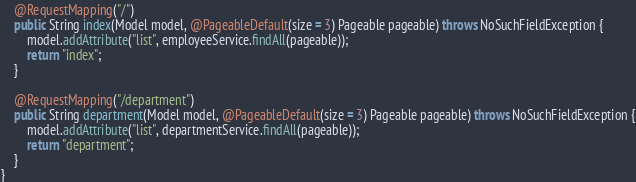<code> <loc_0><loc_0><loc_500><loc_500><_Java_>    @RequestMapping("/")
    public String index(Model model, @PageableDefault(size = 3) Pageable pageable) throws NoSuchFieldException {
        model.addAttribute("list", employeeService.findAll(pageable));
        return "index";
    }

    @RequestMapping("/department")
    public String department(Model model, @PageableDefault(size = 3) Pageable pageable) throws NoSuchFieldException {
        model.addAttribute("list", departmentService.findAll(pageable));
        return "department";
    }
}
</code> 